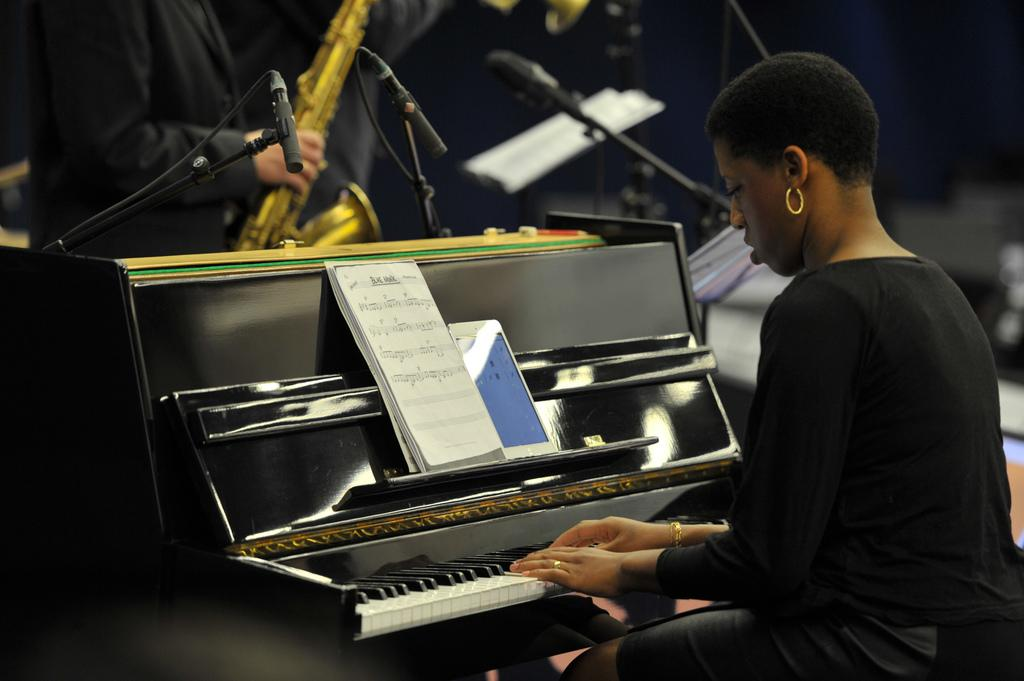What is the main subject of the image? The main subject of the image is a woman. What is the woman doing in the image? The woman is seated and playing a violin. What object is in front of the woman? There is a book in front of the woman. What type of lunch is the woman eating in the image? There is no indication in the image that the woman is eating lunch, so it cannot be determined from the picture. What is the woman looking at in the image? The provided facts do not mention what the woman is looking at, so it cannot be determined from the picture. How many tomatoes are visible in the image? There are no tomatoes present in the image. 